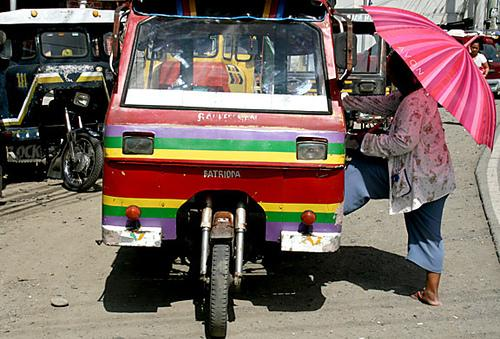What does the front of the automobile shown in this image most resemble? rainbow 